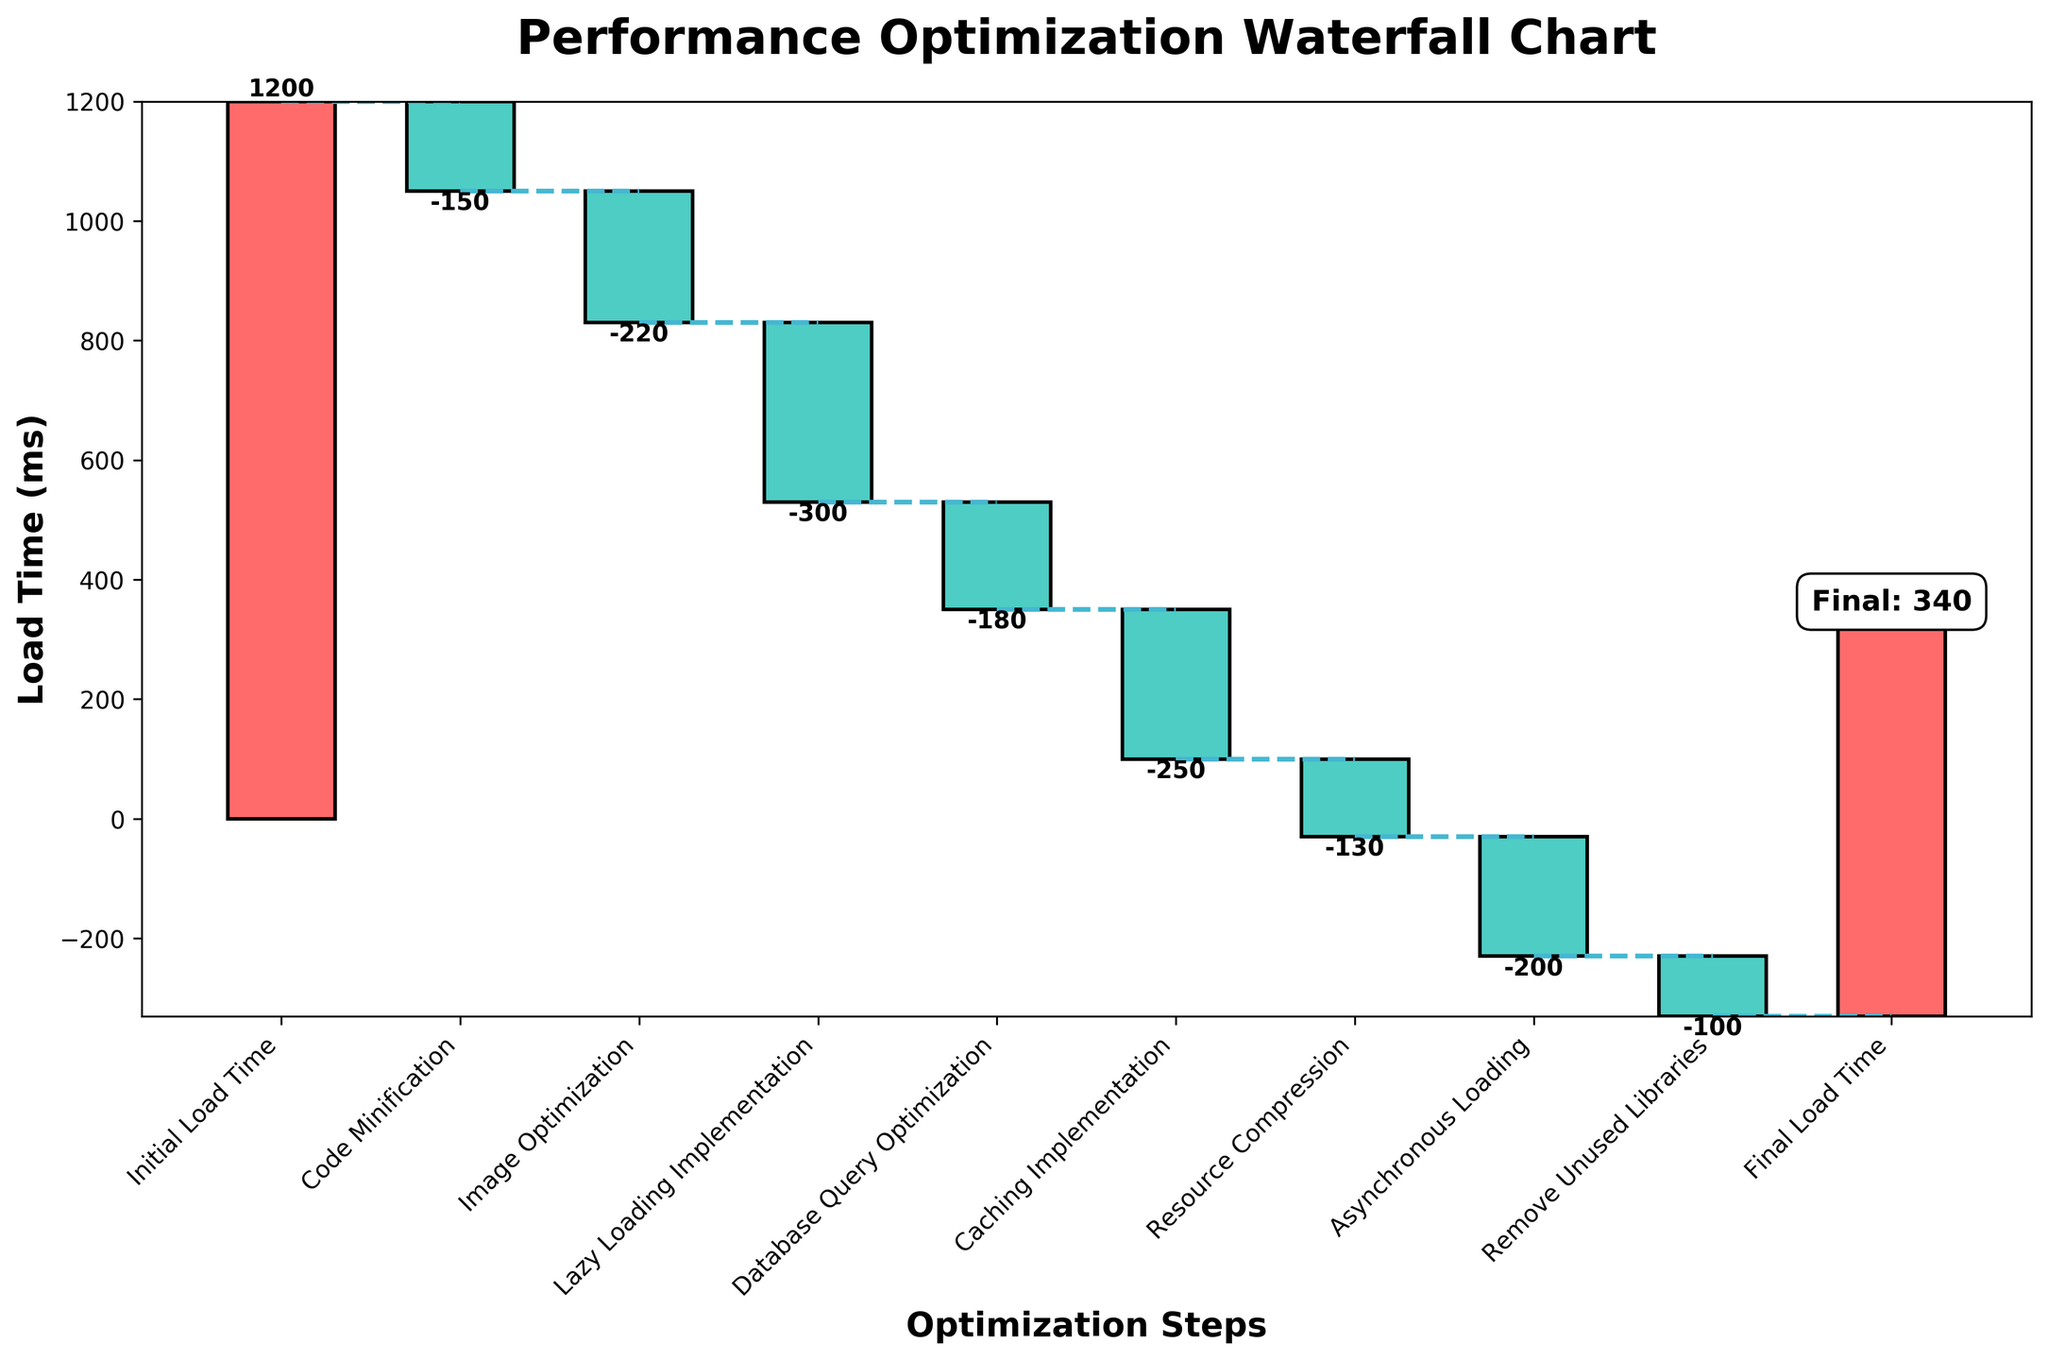What is the title of the chart? The title of the chart is displayed at the top and emphasizes the main theme of the chart. It reads "Performance Optimization Waterfall Chart".
Answer: Performance Optimization Waterfall Chart How many optimization steps are shown in the chart? The x-axis labels each step and there are multiple bars representing these steps. Counting the labels, there are 9 optimization steps plus one for Initial Load Time and one for Final Load Time.
Answer: 11 Which step has the highest positive impact on reducing load time? By scanning the bars, the one with the largest drop (most negative value) represents the highest positive impact. The 'Lazy Loading Implementation' step has an impact of -300 ms, which is greater than others in magnitude.
Answer: Lazy Loading Implementation What is the load time after the 'Code Minification' step? After the 'Code Minification' step, we need to look at the cumulative value just after this step. Initial Load Time is 1200 ms and dropping by 150 ms from 'Code Minification', results in 1200 - 150 = 1050 ms.
Answer: 1050 ms How much total time is saved after all optimization steps? The initial load time is 1200 ms and the final load time is 670 ms. The total time saved is 1200 - 670, which results in 530 ms.
Answer: 530 ms Which optimization steps result in a load time reduction of over 200 ms? From the data, the steps 'Image Optimization' (-220 ms), 'Lazy Loading Implementation' (-300 ms), and 'Asynchronous Loading' (-200 ms) each reduce load time by over 200 ms.
Answer: Image Optimization, Lazy Loading Implementation What is the load time right before the 'Final Load Time'? Looking at the cumulative load time value right before the 'Final Load Time', it follows the 'Remove Unused Libraries' step. Calculating from cumulative values: 670 ms.
Answer: 670 ms How does 'Database Query Optimization' impact the overall load time? The 'Database Query Optimization' step shows a negative impact value of -180 ms, indicating it reduces the load time by 180 ms from the load time at the prior step.
Answer: Reduces by 180 ms What is the cumulative effect of 'Database Query Optimization' and 'Caching Implementation'? The cumulative effect involves summing the impacts of both optimizations: -180 ms + -250 ms which results in a total reduction of 430 ms.
Answer: -430 ms 